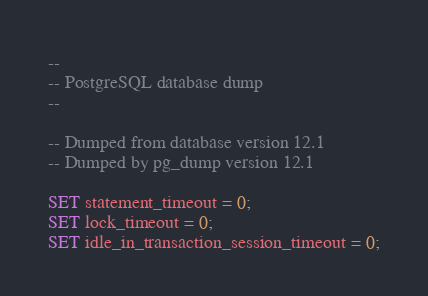<code> <loc_0><loc_0><loc_500><loc_500><_SQL_>--
-- PostgreSQL database dump
--

-- Dumped from database version 12.1
-- Dumped by pg_dump version 12.1

SET statement_timeout = 0;
SET lock_timeout = 0;
SET idle_in_transaction_session_timeout = 0;</code> 